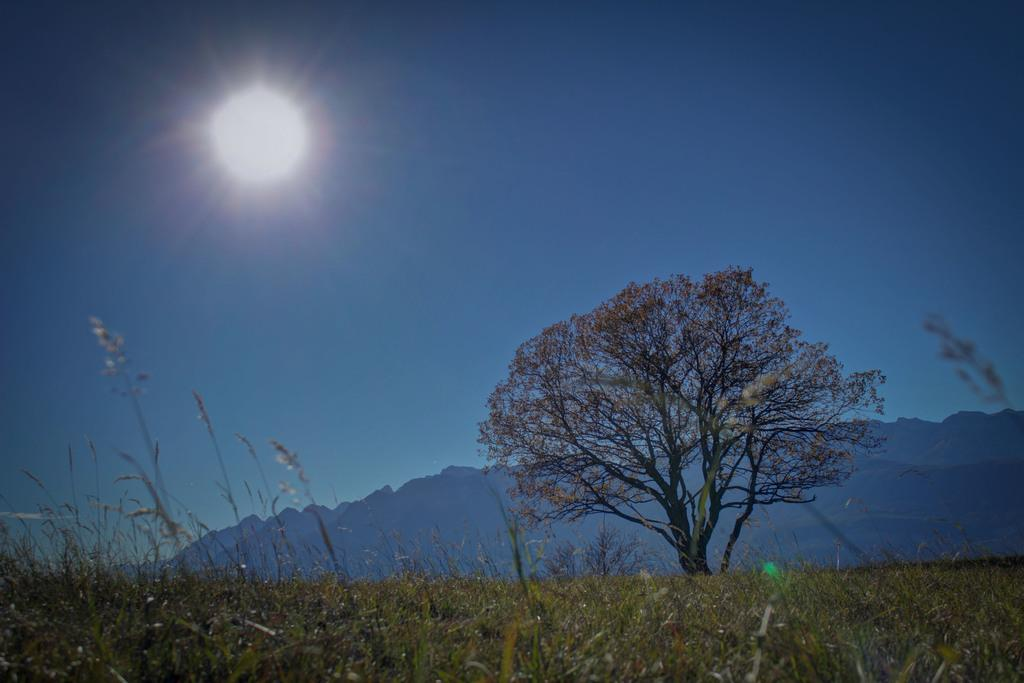What type of vegetation is at the bottom of the image? There is grass at the bottom of the image. What can be seen in the background of the image? There is a tree and mountains in the background of the image. What is visible in the sky in the image? The sky is visible in the background of the image, and the sun is observable in it. Can you tell me how many strings are attached to the tree in the image? There are no strings attached to the tree in the image; it is a natural tree in its environment. 